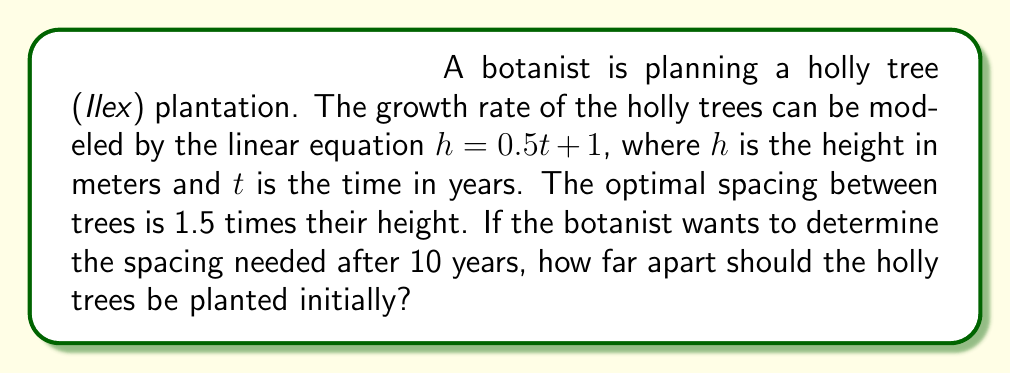Show me your answer to this math problem. 1. First, let's determine the height of the holly trees after 10 years:
   $h = 0.5t + 1$
   $h = 0.5(10) + 1 = 5 + 1 = 6$ meters

2. The optimal spacing is 1.5 times the height:
   Optimal spacing = $1.5 * 6 = 9$ meters

3. To find the initial planting distance, we need to solve the equation:
   $x + 0.5t = 9$, where $x$ is the initial distance and $t = 10$ years

4. Substituting $t = 10$:
   $x + 0.5(10) = 9$
   $x + 5 = 9$

5. Solve for $x$:
   $x = 9 - 5 = 4$ meters

Therefore, the holly trees should be planted 4 meters apart initially to achieve optimal spacing after 10 years.
Answer: 4 meters 